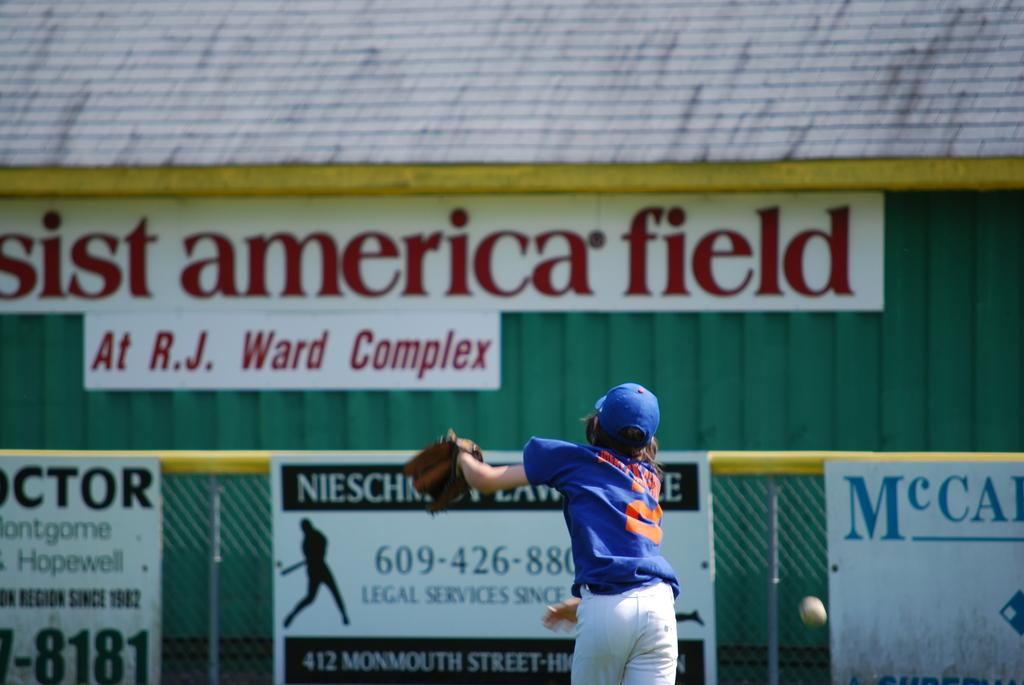<image>
Provide a brief description of the given image. the words america field that are behind a player 